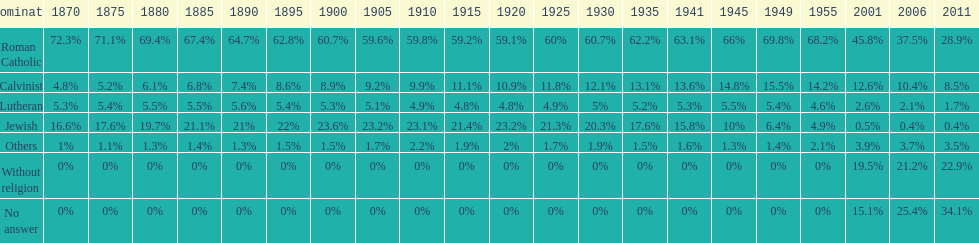Which religious group accounted for the largest proportion in 1880? Roman Catholic. 